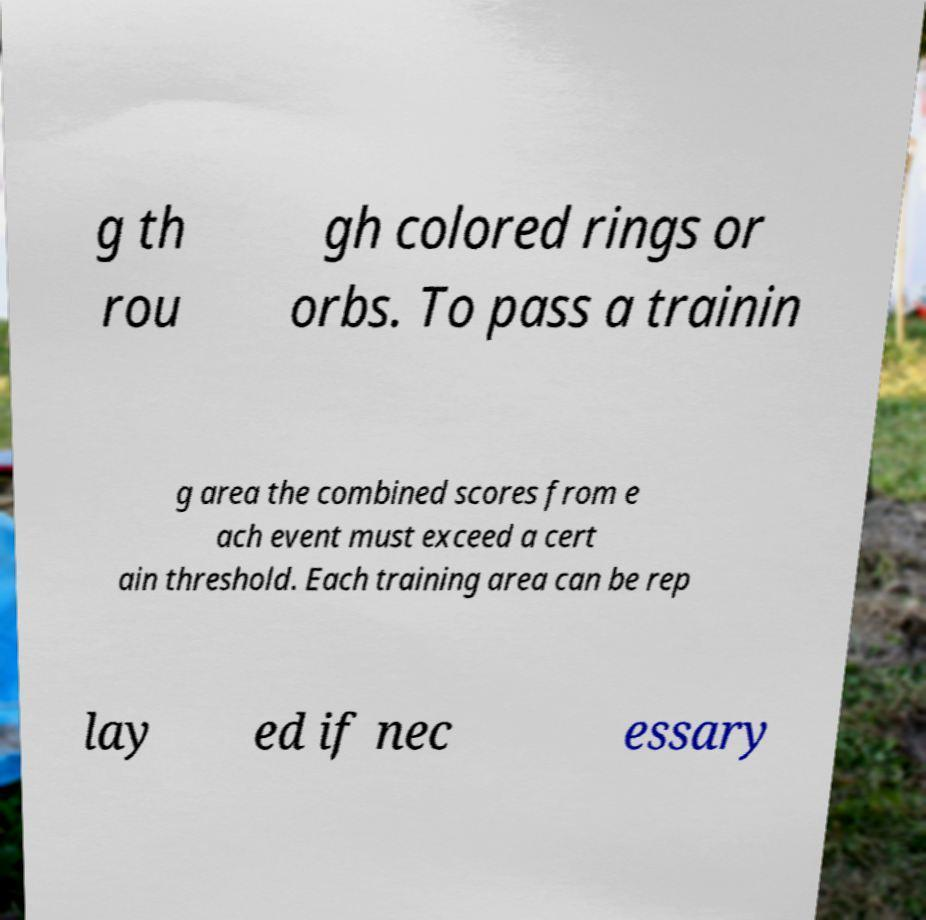I need the written content from this picture converted into text. Can you do that? g th rou gh colored rings or orbs. To pass a trainin g area the combined scores from e ach event must exceed a cert ain threshold. Each training area can be rep lay ed if nec essary 